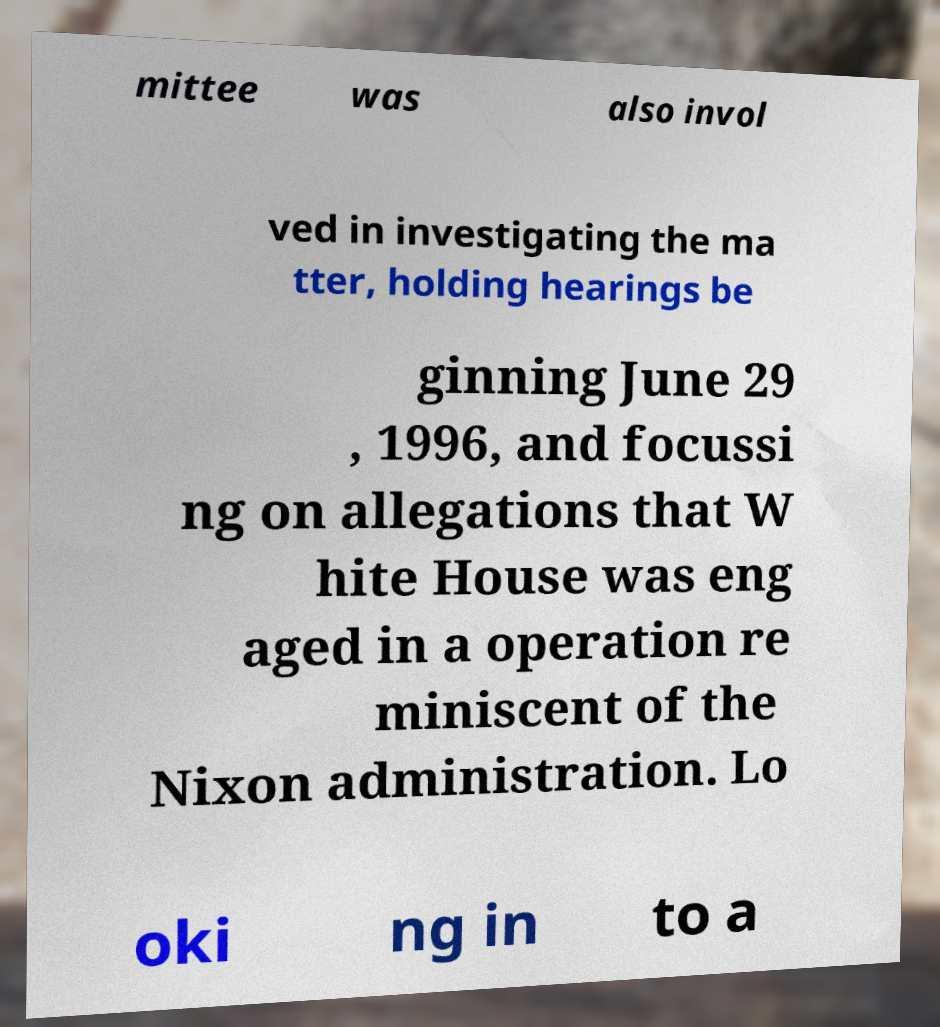Could you extract and type out the text from this image? mittee was also invol ved in investigating the ma tter, holding hearings be ginning June 29 , 1996, and focussi ng on allegations that W hite House was eng aged in a operation re miniscent of the Nixon administration. Lo oki ng in to a 